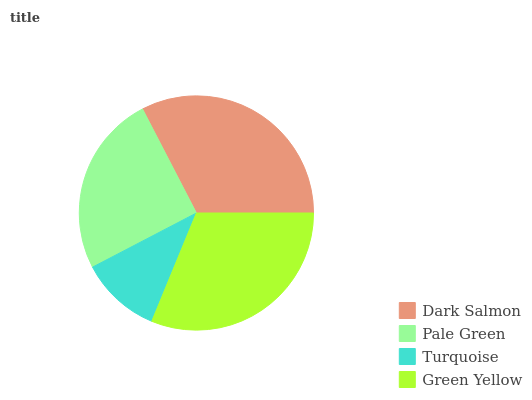Is Turquoise the minimum?
Answer yes or no. Yes. Is Dark Salmon the maximum?
Answer yes or no. Yes. Is Pale Green the minimum?
Answer yes or no. No. Is Pale Green the maximum?
Answer yes or no. No. Is Dark Salmon greater than Pale Green?
Answer yes or no. Yes. Is Pale Green less than Dark Salmon?
Answer yes or no. Yes. Is Pale Green greater than Dark Salmon?
Answer yes or no. No. Is Dark Salmon less than Pale Green?
Answer yes or no. No. Is Green Yellow the high median?
Answer yes or no. Yes. Is Pale Green the low median?
Answer yes or no. Yes. Is Dark Salmon the high median?
Answer yes or no. No. Is Dark Salmon the low median?
Answer yes or no. No. 